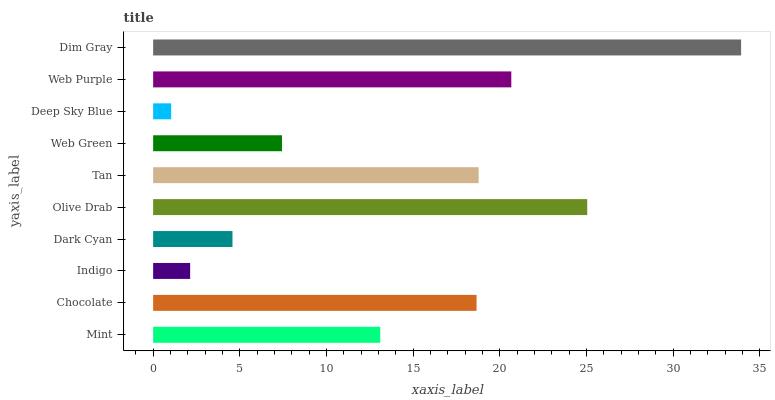Is Deep Sky Blue the minimum?
Answer yes or no. Yes. Is Dim Gray the maximum?
Answer yes or no. Yes. Is Chocolate the minimum?
Answer yes or no. No. Is Chocolate the maximum?
Answer yes or no. No. Is Chocolate greater than Mint?
Answer yes or no. Yes. Is Mint less than Chocolate?
Answer yes or no. Yes. Is Mint greater than Chocolate?
Answer yes or no. No. Is Chocolate less than Mint?
Answer yes or no. No. Is Chocolate the high median?
Answer yes or no. Yes. Is Mint the low median?
Answer yes or no. Yes. Is Mint the high median?
Answer yes or no. No. Is Web Green the low median?
Answer yes or no. No. 